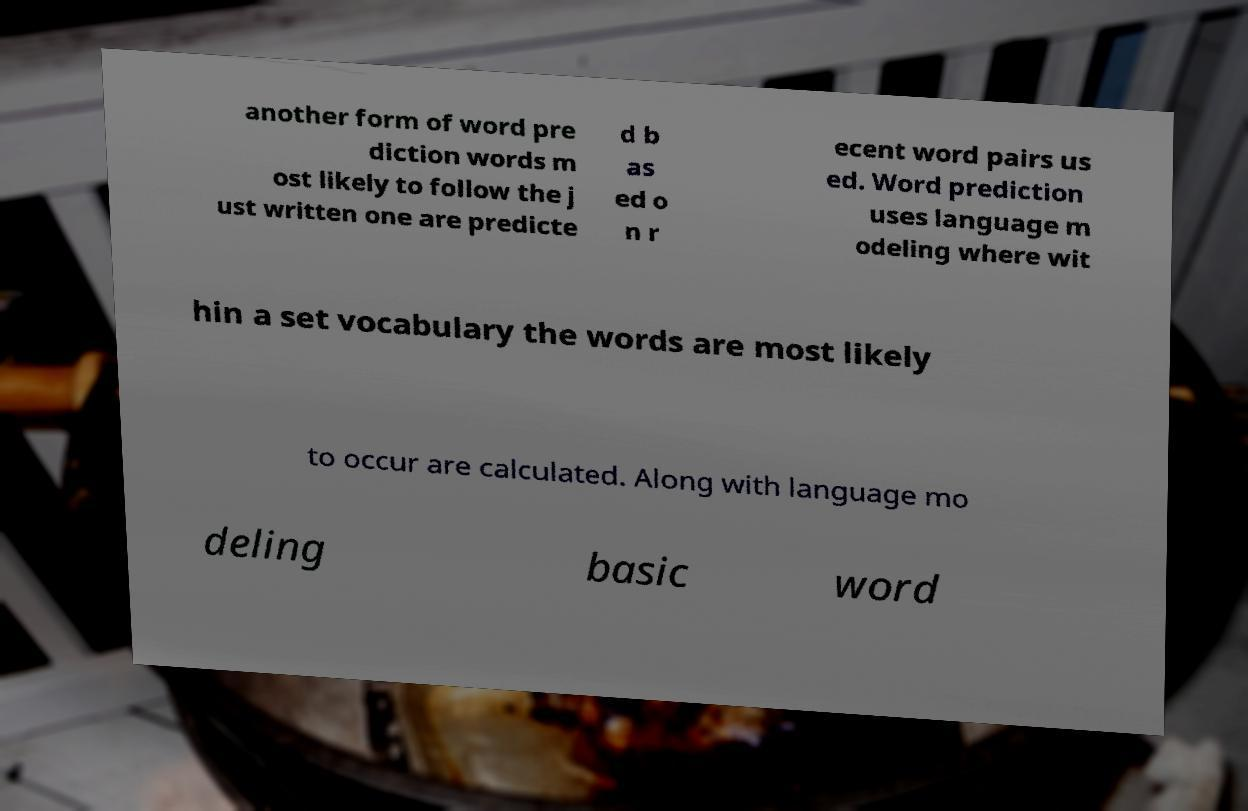Please read and relay the text visible in this image. What does it say? another form of word pre diction words m ost likely to follow the j ust written one are predicte d b as ed o n r ecent word pairs us ed. Word prediction uses language m odeling where wit hin a set vocabulary the words are most likely to occur are calculated. Along with language mo deling basic word 